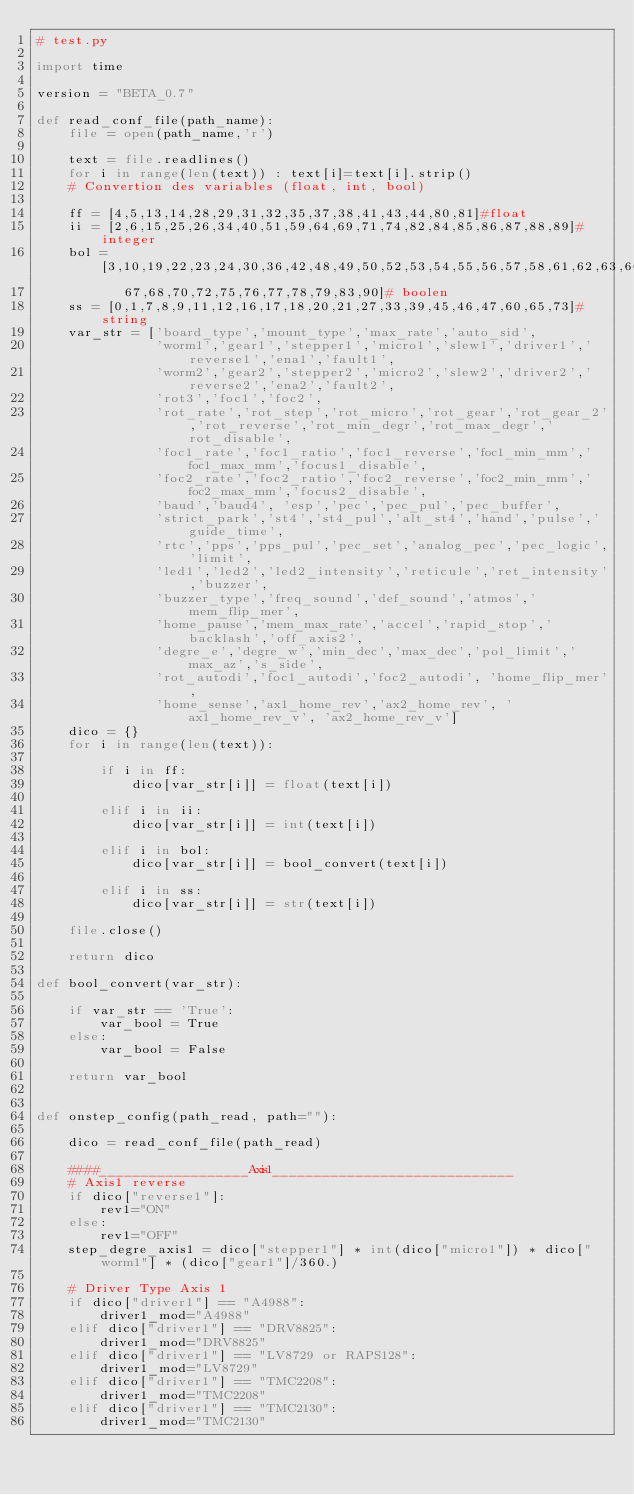<code> <loc_0><loc_0><loc_500><loc_500><_Python_># test.py

import time

version = "BETA_0.7"

def read_conf_file(path_name):
    file = open(path_name,'r')
    
    text = file.readlines()
    for i in range(len(text)) : text[i]=text[i].strip()
    # Convertion des variables (float, int, bool)
    
    ff = [4,5,13,14,28,29,31,32,35,37,38,41,43,44,80,81]#float
    ii = [2,6,15,25,26,34,40,51,59,64,69,71,74,82,84,85,86,87,88,89]# integer
    bol = [3,10,19,22,23,24,30,36,42,48,49,50,52,53,54,55,56,57,58,61,62,63,66,
           67,68,70,72,75,76,77,78,79,83,90]# boolen
    ss = [0,1,7,8,9,11,12,16,17,18,20,21,27,33,39,45,46,47,60,65,73]#string
    var_str = ['board_type','mount_type','max_rate','auto_sid',
               'worm1','gear1','stepper1','micro1','slew1','driver1','reverse1','ena1','fault1',
               'worm2','gear2','stepper2','micro2','slew2','driver2','reverse2','ena2','fault2',
               'rot3','foc1','foc2',
               'rot_rate','rot_step','rot_micro','rot_gear','rot_gear_2','rot_reverse','rot_min_degr','rot_max_degr','rot_disable',
               'foc1_rate','foc1_ratio','foc1_reverse','foc1_min_mm','foc1_max_mm','focus1_disable',
               'foc2_rate','foc2_ratio','foc2_reverse','foc2_min_mm','foc2_max_mm','focus2_disable',
               'baud','baud4', 'esp','pec','pec_pul','pec_buffer',
               'strict_park','st4','st4_pul','alt_st4','hand','pulse','guide_time',
               'rtc','pps','pps_pul','pec_set','analog_pec','pec_logic','limit',
               'led1','led2','led2_intensity','reticule','ret_intensity','buzzer',
               'buzzer_type','freq_sound','def_sound','atmos','mem_flip_mer',
               'home_pause','mem_max_rate','accel','rapid_stop','backlash','off_axis2',
               'degre_e','degre_w','min_dec','max_dec','pol_limit','max_az','s_side',
               'rot_autodi','foc1_autodi','foc2_autodi', 'home_flip_mer',
               'home_sense','ax1_home_rev','ax2_home_rev', 'ax1_home_rev_v', 'ax2_home_rev_v']
    dico = {}
    for i in range(len(text)):
        
        if i in ff:
            dico[var_str[i]] = float(text[i])
            
        elif i in ii:
            dico[var_str[i]] = int(text[i])
            
        elif i in bol:
            dico[var_str[i]] = bool_convert(text[i])
            
        elif i in ss:
            dico[var_str[i]] = str(text[i])

    file.close()
    
    return dico

def bool_convert(var_str):

    if var_str == 'True':
        var_bool = True
    else:
        var_bool = False
        
    return var_bool


def onstep_config(path_read, path=""):
    
    dico = read_conf_file(path_read)
    
    ####__________________Axis1_____________________________
    # Axis1 reverse
    if dico["reverse1"]:
        rev1="ON"
    else:
        rev1="OFF"
    step_degre_axis1 = dico["stepper1"] * int(dico["micro1"]) * dico["worm1"] * (dico["gear1"]/360.)
    
    # Driver Type Axis 1
    if dico["driver1"] == "A4988":
        driver1_mod="A4988"
    elif dico["driver1"] == "DRV8825":
        driver1_mod="DRV8825"
    elif dico["driver1"] == "LV8729 or RAPS128":
        driver1_mod="LV8729"
    elif dico["driver1"] == "TMC2208":
        driver1_mod="TMC2208"
    elif dico["driver1"] == "TMC2130":
        driver1_mod="TMC2130"</code> 